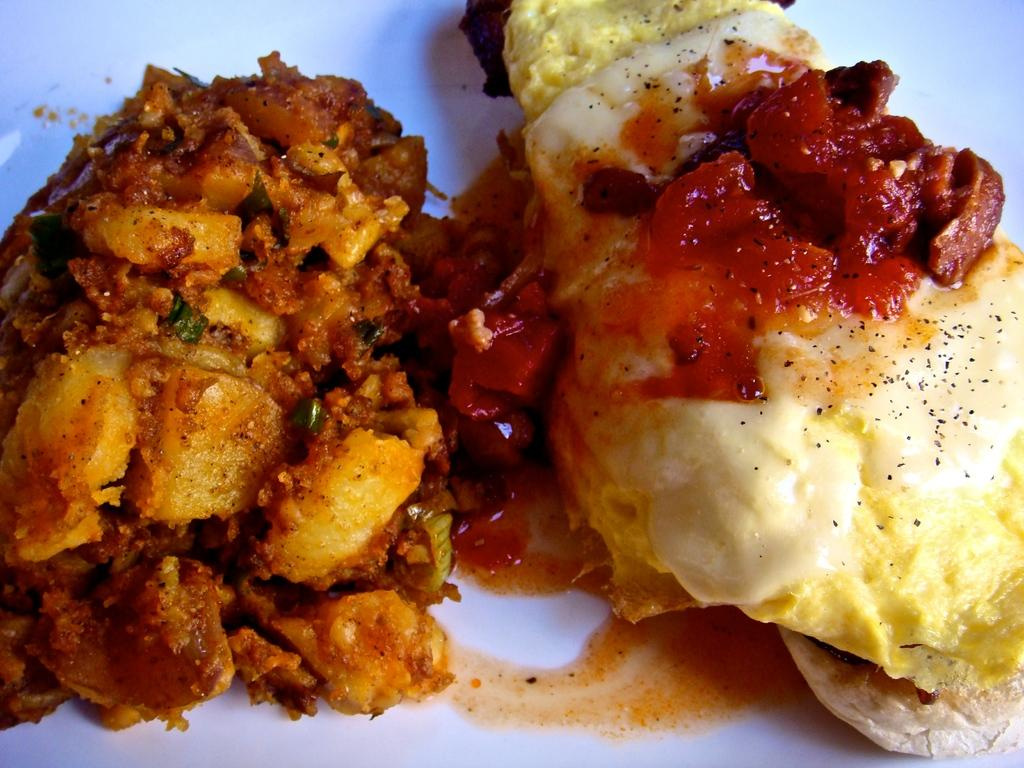What can be seen in the image related to food? There is a food item in the image. What is the color of the surface the food item is placed on? The surface the food item is on is white. What is the interest rate on the food item in the image? There is no interest rate associated with the food item in the image, as it is not a financial product. 